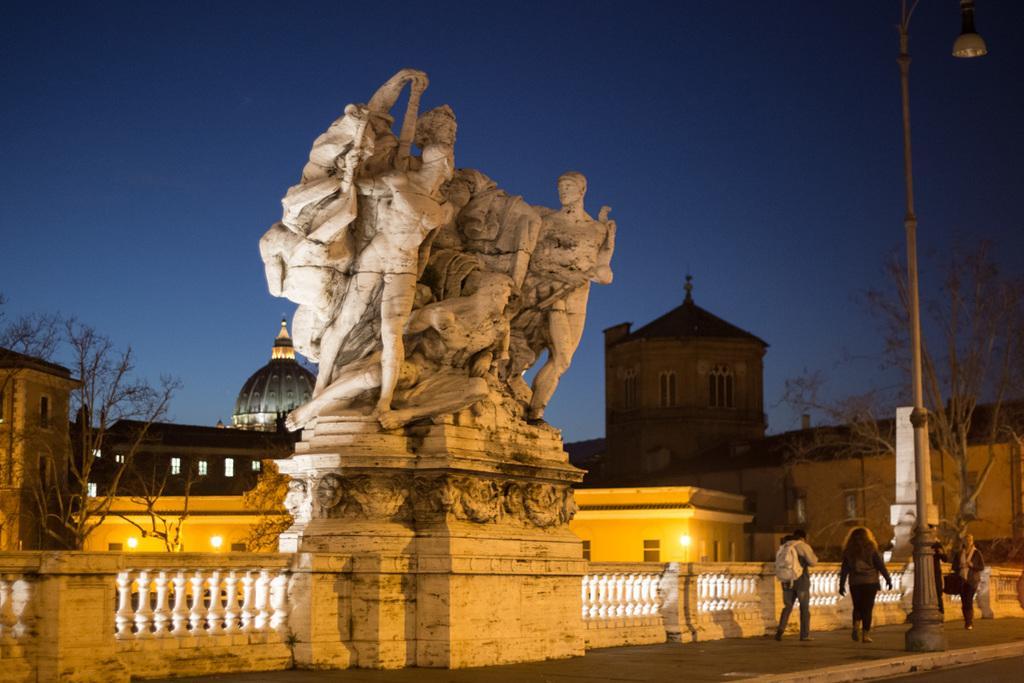Could you give a brief overview of what you see in this image? In the middle there are statues of human beings, In the right side few people are working on the foot path, at the top it's a sky. 